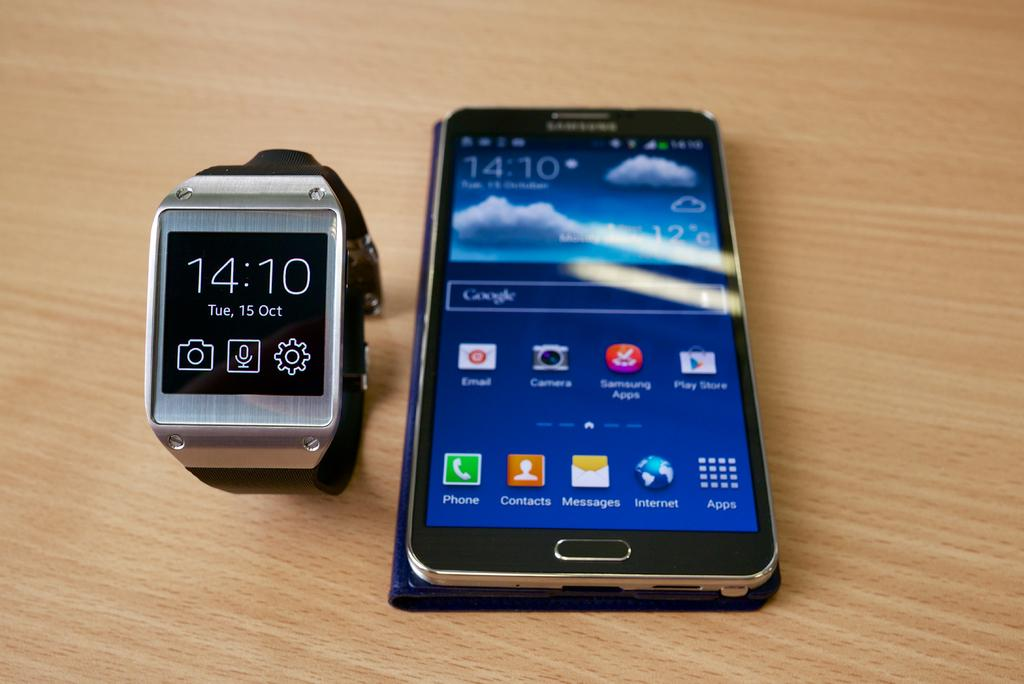Provide a one-sentence caption for the provided image. Android smartphone is on the right of a watch that reads 14:10. 